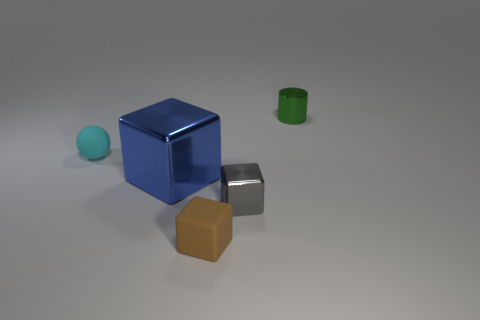Subtract all gray spheres. Subtract all gray cylinders. How many spheres are left? 1 Add 1 big green rubber cylinders. How many objects exist? 6 Subtract all spheres. How many objects are left? 4 Subtract 0 red balls. How many objects are left? 5 Subtract all big metallic things. Subtract all small gray cubes. How many objects are left? 3 Add 5 brown things. How many brown things are left? 6 Add 3 tiny blue matte cylinders. How many tiny blue matte cylinders exist? 3 